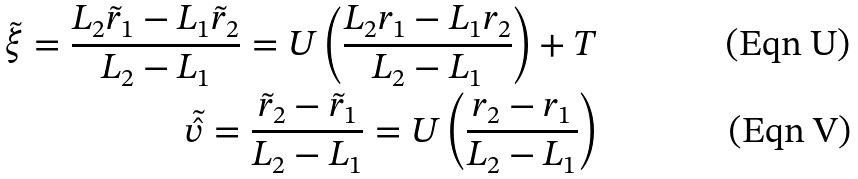<formula> <loc_0><loc_0><loc_500><loc_500>\tilde { \xi } = \frac { L _ { 2 } \tilde { r } _ { 1 } - L _ { 1 } \tilde { r } _ { 2 } } { L _ { 2 } - L _ { 1 } } = U \left ( \frac { L _ { 2 } r _ { 1 } - L _ { 1 } r _ { 2 } } { L _ { 2 } - L _ { 1 } } \right ) + T \\ \tilde { \hat { v } } = \frac { \tilde { r } _ { 2 } - \tilde { r } _ { 1 } } { L _ { 2 } - L _ { 1 } } = U \left ( \frac { r _ { 2 } - r _ { 1 } } { L _ { 2 } - L _ { 1 } } \right )</formula> 